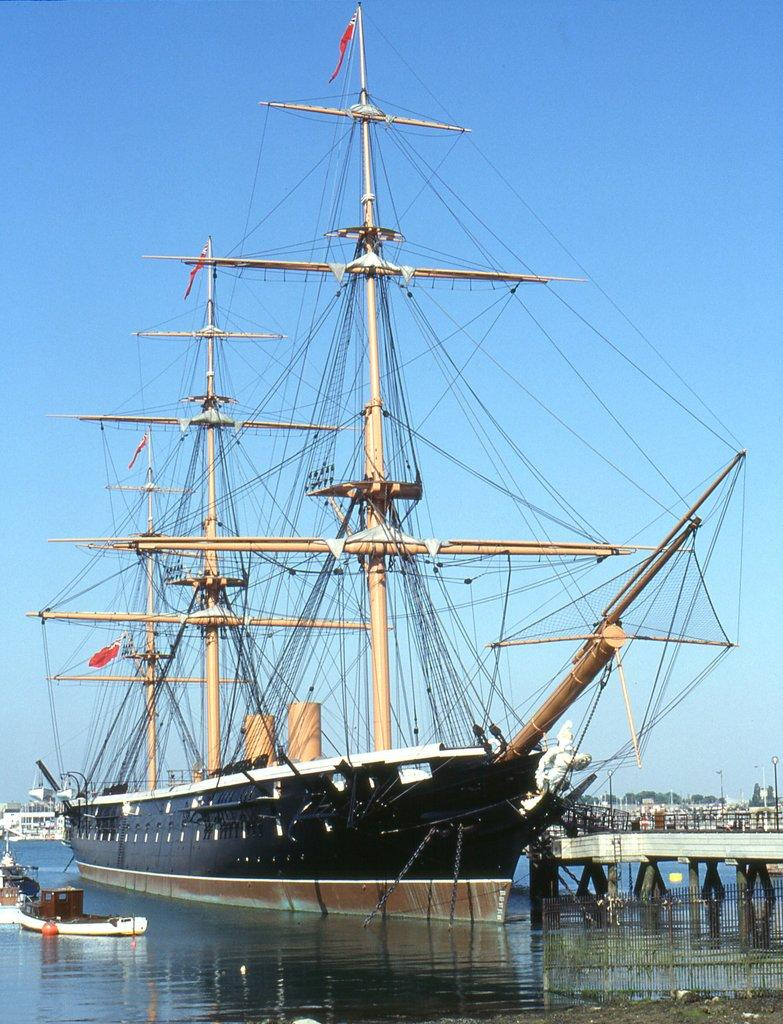What type of vehicle is in the image? There is a ship in the image. Are there any other similar vehicles in the image? Yes, there are boats in the image. Where are the ship and boats located? The ship and boats are on the water. What other structure can be seen in the image? There is a bridge in the image. What can be seen in the background of the image? The sky is visible in the background of the image. How many yams are being sorted in the image? There are no yams present in the image. 